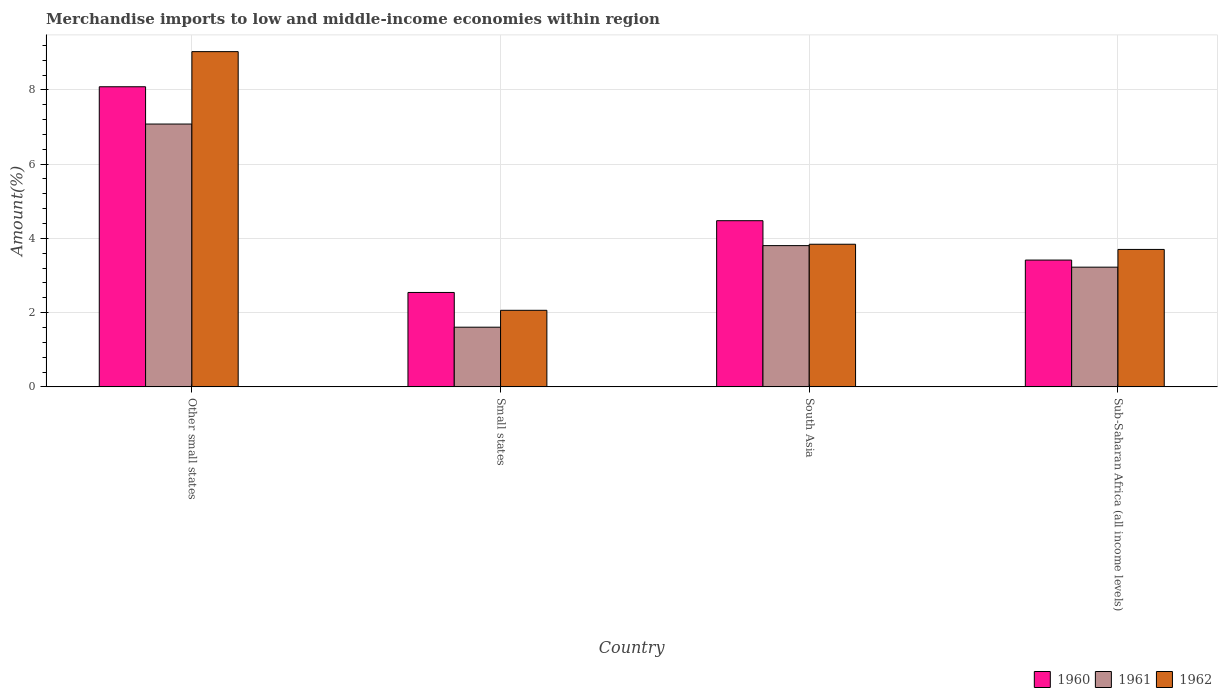Are the number of bars per tick equal to the number of legend labels?
Your answer should be compact. Yes. How many bars are there on the 2nd tick from the right?
Offer a terse response. 3. What is the label of the 4th group of bars from the left?
Keep it short and to the point. Sub-Saharan Africa (all income levels). In how many cases, is the number of bars for a given country not equal to the number of legend labels?
Offer a very short reply. 0. What is the percentage of amount earned from merchandise imports in 1960 in Small states?
Provide a short and direct response. 2.54. Across all countries, what is the maximum percentage of amount earned from merchandise imports in 1960?
Your response must be concise. 8.08. Across all countries, what is the minimum percentage of amount earned from merchandise imports in 1961?
Give a very brief answer. 1.61. In which country was the percentage of amount earned from merchandise imports in 1961 maximum?
Offer a terse response. Other small states. In which country was the percentage of amount earned from merchandise imports in 1960 minimum?
Offer a very short reply. Small states. What is the total percentage of amount earned from merchandise imports in 1961 in the graph?
Your answer should be compact. 15.72. What is the difference between the percentage of amount earned from merchandise imports in 1960 in Other small states and that in Sub-Saharan Africa (all income levels)?
Keep it short and to the point. 4.67. What is the difference between the percentage of amount earned from merchandise imports in 1962 in Sub-Saharan Africa (all income levels) and the percentage of amount earned from merchandise imports in 1960 in Other small states?
Your answer should be compact. -4.38. What is the average percentage of amount earned from merchandise imports in 1960 per country?
Provide a succinct answer. 4.63. What is the difference between the percentage of amount earned from merchandise imports of/in 1961 and percentage of amount earned from merchandise imports of/in 1960 in Other small states?
Make the answer very short. -1. What is the ratio of the percentage of amount earned from merchandise imports in 1960 in Small states to that in Sub-Saharan Africa (all income levels)?
Provide a short and direct response. 0.74. Is the percentage of amount earned from merchandise imports in 1962 in Other small states less than that in Sub-Saharan Africa (all income levels)?
Give a very brief answer. No. Is the difference between the percentage of amount earned from merchandise imports in 1961 in Other small states and Small states greater than the difference between the percentage of amount earned from merchandise imports in 1960 in Other small states and Small states?
Provide a short and direct response. No. What is the difference between the highest and the second highest percentage of amount earned from merchandise imports in 1960?
Offer a very short reply. 4.67. What is the difference between the highest and the lowest percentage of amount earned from merchandise imports in 1960?
Your answer should be very brief. 5.54. What does the 3rd bar from the right in Sub-Saharan Africa (all income levels) represents?
Your answer should be very brief. 1960. How many bars are there?
Your response must be concise. 12. How many countries are there in the graph?
Your answer should be compact. 4. What is the difference between two consecutive major ticks on the Y-axis?
Your answer should be compact. 2. Does the graph contain any zero values?
Offer a very short reply. No. Where does the legend appear in the graph?
Provide a succinct answer. Bottom right. How many legend labels are there?
Offer a very short reply. 3. How are the legend labels stacked?
Your answer should be compact. Horizontal. What is the title of the graph?
Ensure brevity in your answer.  Merchandise imports to low and middle-income economies within region. Does "1991" appear as one of the legend labels in the graph?
Keep it short and to the point. No. What is the label or title of the Y-axis?
Your answer should be compact. Amount(%). What is the Amount(%) in 1960 in Other small states?
Your response must be concise. 8.08. What is the Amount(%) in 1961 in Other small states?
Your answer should be compact. 7.08. What is the Amount(%) of 1962 in Other small states?
Offer a very short reply. 9.03. What is the Amount(%) of 1960 in Small states?
Give a very brief answer. 2.54. What is the Amount(%) in 1961 in Small states?
Make the answer very short. 1.61. What is the Amount(%) in 1962 in Small states?
Your answer should be very brief. 2.06. What is the Amount(%) of 1960 in South Asia?
Provide a short and direct response. 4.48. What is the Amount(%) of 1961 in South Asia?
Provide a short and direct response. 3.8. What is the Amount(%) in 1962 in South Asia?
Your response must be concise. 3.84. What is the Amount(%) in 1960 in Sub-Saharan Africa (all income levels)?
Your response must be concise. 3.42. What is the Amount(%) of 1961 in Sub-Saharan Africa (all income levels)?
Offer a terse response. 3.22. What is the Amount(%) of 1962 in Sub-Saharan Africa (all income levels)?
Your answer should be compact. 3.7. Across all countries, what is the maximum Amount(%) of 1960?
Give a very brief answer. 8.08. Across all countries, what is the maximum Amount(%) in 1961?
Offer a terse response. 7.08. Across all countries, what is the maximum Amount(%) of 1962?
Your answer should be very brief. 9.03. Across all countries, what is the minimum Amount(%) in 1960?
Offer a terse response. 2.54. Across all countries, what is the minimum Amount(%) of 1961?
Ensure brevity in your answer.  1.61. Across all countries, what is the minimum Amount(%) in 1962?
Offer a very short reply. 2.06. What is the total Amount(%) of 1960 in the graph?
Keep it short and to the point. 18.52. What is the total Amount(%) of 1961 in the graph?
Provide a succinct answer. 15.72. What is the total Amount(%) of 1962 in the graph?
Keep it short and to the point. 18.64. What is the difference between the Amount(%) of 1960 in Other small states and that in Small states?
Offer a very short reply. 5.54. What is the difference between the Amount(%) in 1961 in Other small states and that in Small states?
Ensure brevity in your answer.  5.47. What is the difference between the Amount(%) in 1962 in Other small states and that in Small states?
Provide a short and direct response. 6.97. What is the difference between the Amount(%) of 1960 in Other small states and that in South Asia?
Give a very brief answer. 3.61. What is the difference between the Amount(%) in 1961 in Other small states and that in South Asia?
Your answer should be very brief. 3.28. What is the difference between the Amount(%) of 1962 in Other small states and that in South Asia?
Your response must be concise. 5.19. What is the difference between the Amount(%) of 1960 in Other small states and that in Sub-Saharan Africa (all income levels)?
Provide a succinct answer. 4.67. What is the difference between the Amount(%) in 1961 in Other small states and that in Sub-Saharan Africa (all income levels)?
Give a very brief answer. 3.86. What is the difference between the Amount(%) in 1962 in Other small states and that in Sub-Saharan Africa (all income levels)?
Make the answer very short. 5.33. What is the difference between the Amount(%) in 1960 in Small states and that in South Asia?
Make the answer very short. -1.93. What is the difference between the Amount(%) in 1961 in Small states and that in South Asia?
Your answer should be very brief. -2.2. What is the difference between the Amount(%) of 1962 in Small states and that in South Asia?
Offer a terse response. -1.78. What is the difference between the Amount(%) in 1960 in Small states and that in Sub-Saharan Africa (all income levels)?
Make the answer very short. -0.87. What is the difference between the Amount(%) in 1961 in Small states and that in Sub-Saharan Africa (all income levels)?
Your response must be concise. -1.62. What is the difference between the Amount(%) of 1962 in Small states and that in Sub-Saharan Africa (all income levels)?
Keep it short and to the point. -1.64. What is the difference between the Amount(%) in 1960 in South Asia and that in Sub-Saharan Africa (all income levels)?
Your answer should be compact. 1.06. What is the difference between the Amount(%) in 1961 in South Asia and that in Sub-Saharan Africa (all income levels)?
Your response must be concise. 0.58. What is the difference between the Amount(%) of 1962 in South Asia and that in Sub-Saharan Africa (all income levels)?
Keep it short and to the point. 0.14. What is the difference between the Amount(%) in 1960 in Other small states and the Amount(%) in 1961 in Small states?
Provide a succinct answer. 6.48. What is the difference between the Amount(%) in 1960 in Other small states and the Amount(%) in 1962 in Small states?
Ensure brevity in your answer.  6.02. What is the difference between the Amount(%) in 1961 in Other small states and the Amount(%) in 1962 in Small states?
Your response must be concise. 5.02. What is the difference between the Amount(%) of 1960 in Other small states and the Amount(%) of 1961 in South Asia?
Your response must be concise. 4.28. What is the difference between the Amount(%) in 1960 in Other small states and the Amount(%) in 1962 in South Asia?
Make the answer very short. 4.24. What is the difference between the Amount(%) in 1961 in Other small states and the Amount(%) in 1962 in South Asia?
Offer a terse response. 3.24. What is the difference between the Amount(%) in 1960 in Other small states and the Amount(%) in 1961 in Sub-Saharan Africa (all income levels)?
Provide a short and direct response. 4.86. What is the difference between the Amount(%) of 1960 in Other small states and the Amount(%) of 1962 in Sub-Saharan Africa (all income levels)?
Offer a terse response. 4.38. What is the difference between the Amount(%) of 1961 in Other small states and the Amount(%) of 1962 in Sub-Saharan Africa (all income levels)?
Provide a short and direct response. 3.38. What is the difference between the Amount(%) of 1960 in Small states and the Amount(%) of 1961 in South Asia?
Provide a short and direct response. -1.26. What is the difference between the Amount(%) of 1960 in Small states and the Amount(%) of 1962 in South Asia?
Make the answer very short. -1.3. What is the difference between the Amount(%) in 1961 in Small states and the Amount(%) in 1962 in South Asia?
Make the answer very short. -2.23. What is the difference between the Amount(%) in 1960 in Small states and the Amount(%) in 1961 in Sub-Saharan Africa (all income levels)?
Keep it short and to the point. -0.68. What is the difference between the Amount(%) in 1960 in Small states and the Amount(%) in 1962 in Sub-Saharan Africa (all income levels)?
Provide a succinct answer. -1.16. What is the difference between the Amount(%) in 1961 in Small states and the Amount(%) in 1962 in Sub-Saharan Africa (all income levels)?
Offer a very short reply. -2.09. What is the difference between the Amount(%) in 1960 in South Asia and the Amount(%) in 1961 in Sub-Saharan Africa (all income levels)?
Provide a succinct answer. 1.25. What is the difference between the Amount(%) in 1960 in South Asia and the Amount(%) in 1962 in Sub-Saharan Africa (all income levels)?
Offer a very short reply. 0.77. What is the difference between the Amount(%) of 1961 in South Asia and the Amount(%) of 1962 in Sub-Saharan Africa (all income levels)?
Your response must be concise. 0.1. What is the average Amount(%) of 1960 per country?
Make the answer very short. 4.63. What is the average Amount(%) of 1961 per country?
Make the answer very short. 3.93. What is the average Amount(%) in 1962 per country?
Your answer should be compact. 4.66. What is the difference between the Amount(%) of 1960 and Amount(%) of 1961 in Other small states?
Provide a short and direct response. 1. What is the difference between the Amount(%) in 1960 and Amount(%) in 1962 in Other small states?
Your response must be concise. -0.95. What is the difference between the Amount(%) in 1961 and Amount(%) in 1962 in Other small states?
Provide a short and direct response. -1.95. What is the difference between the Amount(%) of 1960 and Amount(%) of 1961 in Small states?
Make the answer very short. 0.94. What is the difference between the Amount(%) of 1960 and Amount(%) of 1962 in Small states?
Provide a short and direct response. 0.48. What is the difference between the Amount(%) in 1961 and Amount(%) in 1962 in Small states?
Offer a very short reply. -0.46. What is the difference between the Amount(%) in 1960 and Amount(%) in 1961 in South Asia?
Offer a very short reply. 0.67. What is the difference between the Amount(%) in 1960 and Amount(%) in 1962 in South Asia?
Your response must be concise. 0.63. What is the difference between the Amount(%) in 1961 and Amount(%) in 1962 in South Asia?
Make the answer very short. -0.04. What is the difference between the Amount(%) in 1960 and Amount(%) in 1961 in Sub-Saharan Africa (all income levels)?
Provide a succinct answer. 0.19. What is the difference between the Amount(%) in 1960 and Amount(%) in 1962 in Sub-Saharan Africa (all income levels)?
Give a very brief answer. -0.29. What is the difference between the Amount(%) in 1961 and Amount(%) in 1962 in Sub-Saharan Africa (all income levels)?
Offer a very short reply. -0.48. What is the ratio of the Amount(%) in 1960 in Other small states to that in Small states?
Your answer should be compact. 3.18. What is the ratio of the Amount(%) in 1961 in Other small states to that in Small states?
Give a very brief answer. 4.4. What is the ratio of the Amount(%) of 1962 in Other small states to that in Small states?
Offer a very short reply. 4.38. What is the ratio of the Amount(%) in 1960 in Other small states to that in South Asia?
Ensure brevity in your answer.  1.81. What is the ratio of the Amount(%) in 1961 in Other small states to that in South Asia?
Give a very brief answer. 1.86. What is the ratio of the Amount(%) of 1962 in Other small states to that in South Asia?
Your answer should be very brief. 2.35. What is the ratio of the Amount(%) of 1960 in Other small states to that in Sub-Saharan Africa (all income levels)?
Make the answer very short. 2.37. What is the ratio of the Amount(%) of 1961 in Other small states to that in Sub-Saharan Africa (all income levels)?
Offer a terse response. 2.2. What is the ratio of the Amount(%) in 1962 in Other small states to that in Sub-Saharan Africa (all income levels)?
Give a very brief answer. 2.44. What is the ratio of the Amount(%) of 1960 in Small states to that in South Asia?
Your response must be concise. 0.57. What is the ratio of the Amount(%) in 1961 in Small states to that in South Asia?
Keep it short and to the point. 0.42. What is the ratio of the Amount(%) in 1962 in Small states to that in South Asia?
Offer a very short reply. 0.54. What is the ratio of the Amount(%) in 1960 in Small states to that in Sub-Saharan Africa (all income levels)?
Offer a terse response. 0.74. What is the ratio of the Amount(%) of 1961 in Small states to that in Sub-Saharan Africa (all income levels)?
Offer a terse response. 0.5. What is the ratio of the Amount(%) of 1962 in Small states to that in Sub-Saharan Africa (all income levels)?
Keep it short and to the point. 0.56. What is the ratio of the Amount(%) of 1960 in South Asia to that in Sub-Saharan Africa (all income levels)?
Your answer should be very brief. 1.31. What is the ratio of the Amount(%) in 1961 in South Asia to that in Sub-Saharan Africa (all income levels)?
Give a very brief answer. 1.18. What is the ratio of the Amount(%) of 1962 in South Asia to that in Sub-Saharan Africa (all income levels)?
Keep it short and to the point. 1.04. What is the difference between the highest and the second highest Amount(%) in 1960?
Make the answer very short. 3.61. What is the difference between the highest and the second highest Amount(%) in 1961?
Offer a terse response. 3.28. What is the difference between the highest and the second highest Amount(%) in 1962?
Make the answer very short. 5.19. What is the difference between the highest and the lowest Amount(%) of 1960?
Provide a succinct answer. 5.54. What is the difference between the highest and the lowest Amount(%) in 1961?
Give a very brief answer. 5.47. What is the difference between the highest and the lowest Amount(%) in 1962?
Keep it short and to the point. 6.97. 